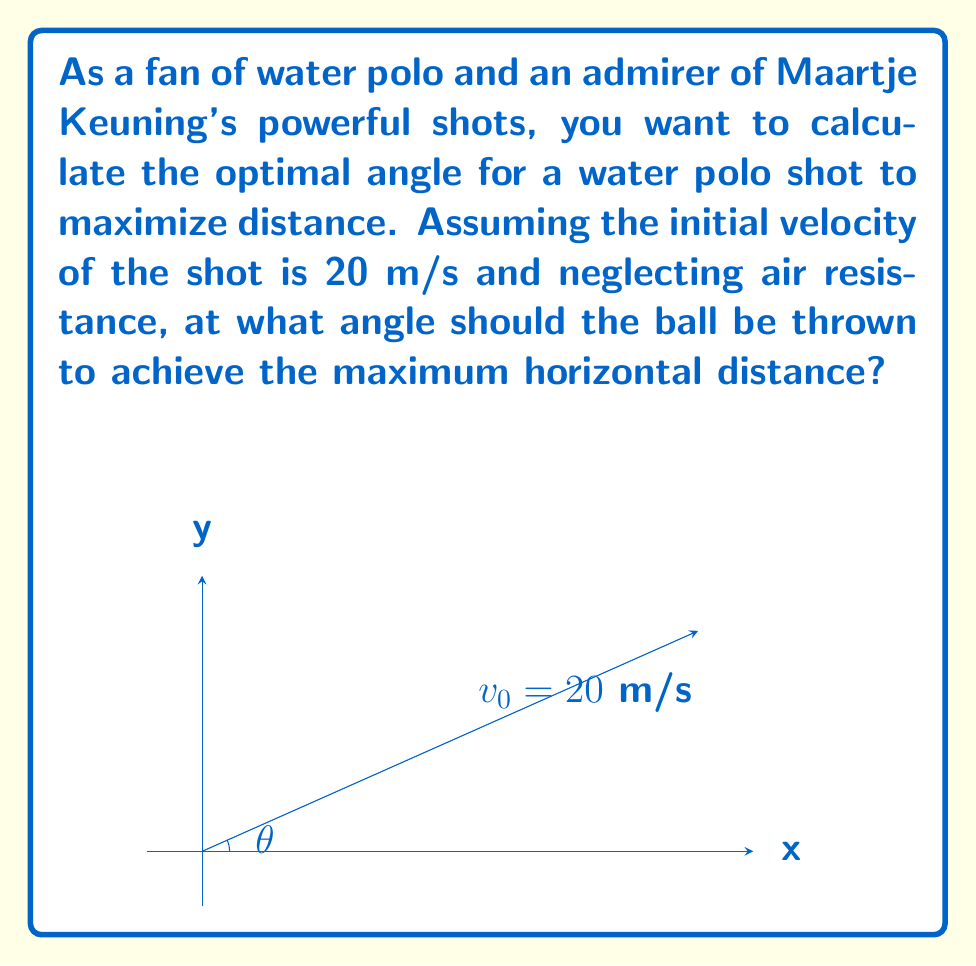What is the answer to this math problem? To solve this problem, we'll use the equations of projectile motion and find the angle that maximizes the horizontal distance.

1) The horizontal distance (range) of a projectile is given by:

   $$R = \frac{v_0^2 \sin(2\theta)}{g}$$

   where $v_0$ is the initial velocity, $\theta$ is the launch angle, and $g$ is the acceleration due to gravity (9.8 m/s²).

2) To find the maximum range, we need to maximize $\sin(2\theta)$. The sine function reaches its maximum value of 1 when its argument is 90°.

3) Therefore, the maximum range occurs when:

   $$2\theta = 90°$$
   $$\theta = 45°$$

4) We can verify this by calculating the range for $\theta = 45°$:

   $$R = \frac{(20 \text{ m/s})^2 \sin(2 \cdot 45°)}{9.8 \text{ m/s}^2}$$
   $$R = \frac{400 \text{ m}^2 \cdot 1}{9.8 \text{ m/s}^2} \approx 40.82 \text{ m}$$

5) This is indeed the maximum range for the given initial velocity.

Therefore, to maximize the horizontal distance of the water polo shot, Maartje Keuning should throw the ball at a 45° angle to the horizontal.
Answer: 45° 